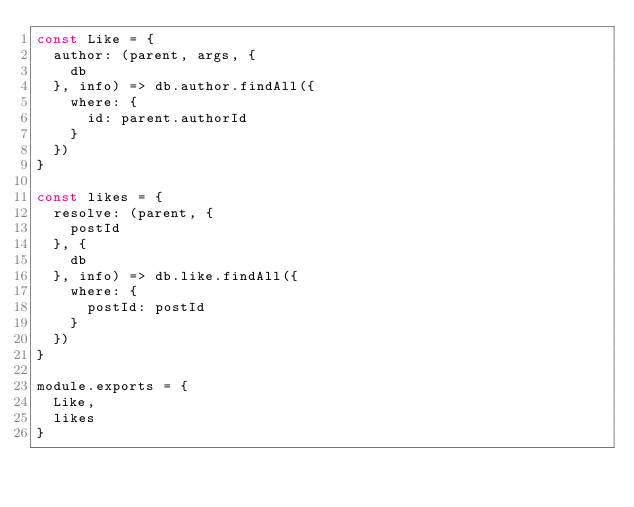<code> <loc_0><loc_0><loc_500><loc_500><_JavaScript_>const Like = {
  author: (parent, args, {
    db
  }, info) => db.author.findAll({
    where: {
      id: parent.authorId
    }
  })
}

const likes = {
  resolve: (parent, {
    postId
  }, {
    db
  }, info) => db.like.findAll({
    where: {
      postId: postId
    }
  })
}

module.exports = {
  Like,
  likes
}</code> 